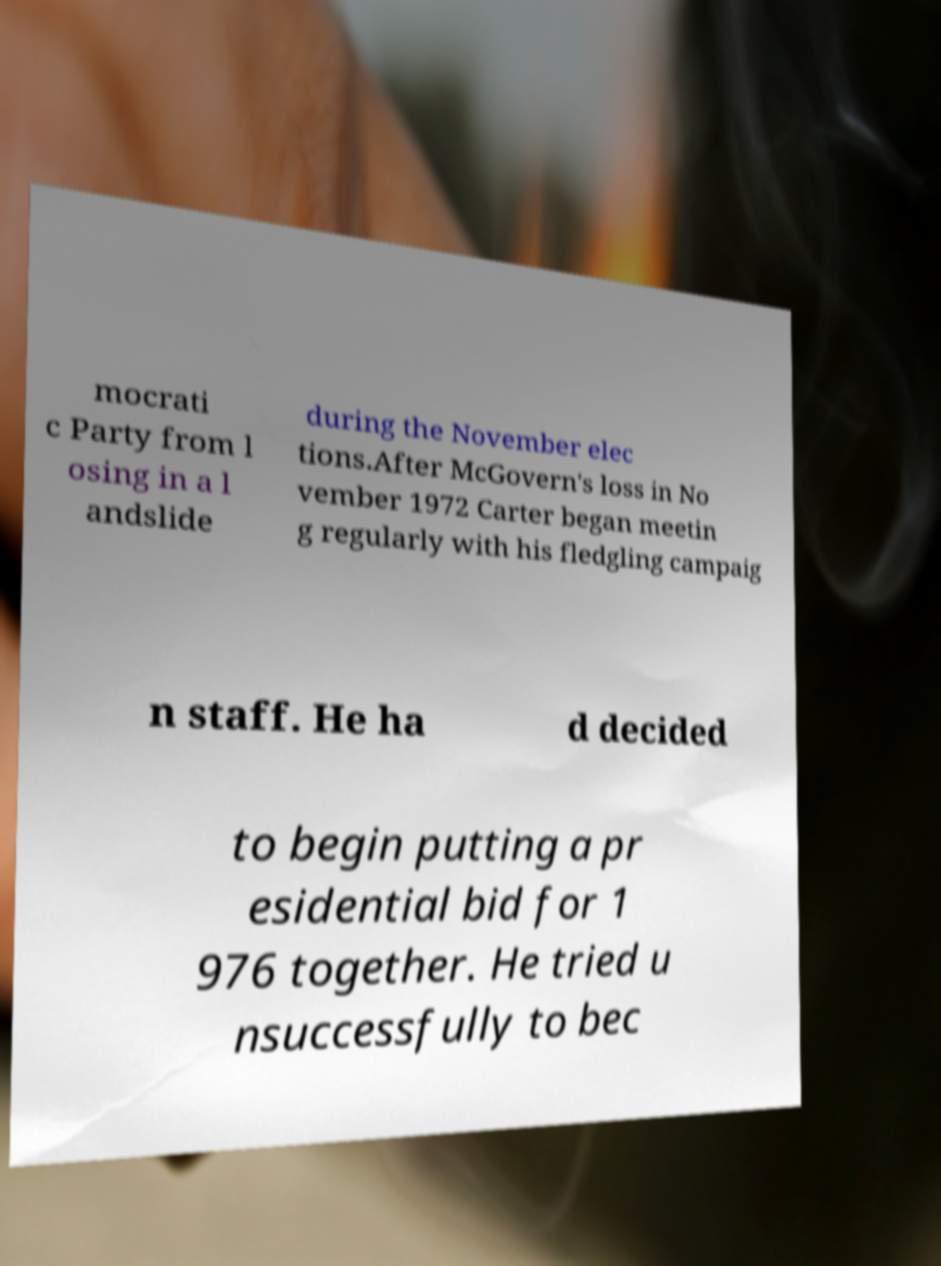Can you read and provide the text displayed in the image?This photo seems to have some interesting text. Can you extract and type it out for me? mocrati c Party from l osing in a l andslide during the November elec tions.After McGovern's loss in No vember 1972 Carter began meetin g regularly with his fledgling campaig n staff. He ha d decided to begin putting a pr esidential bid for 1 976 together. He tried u nsuccessfully to bec 